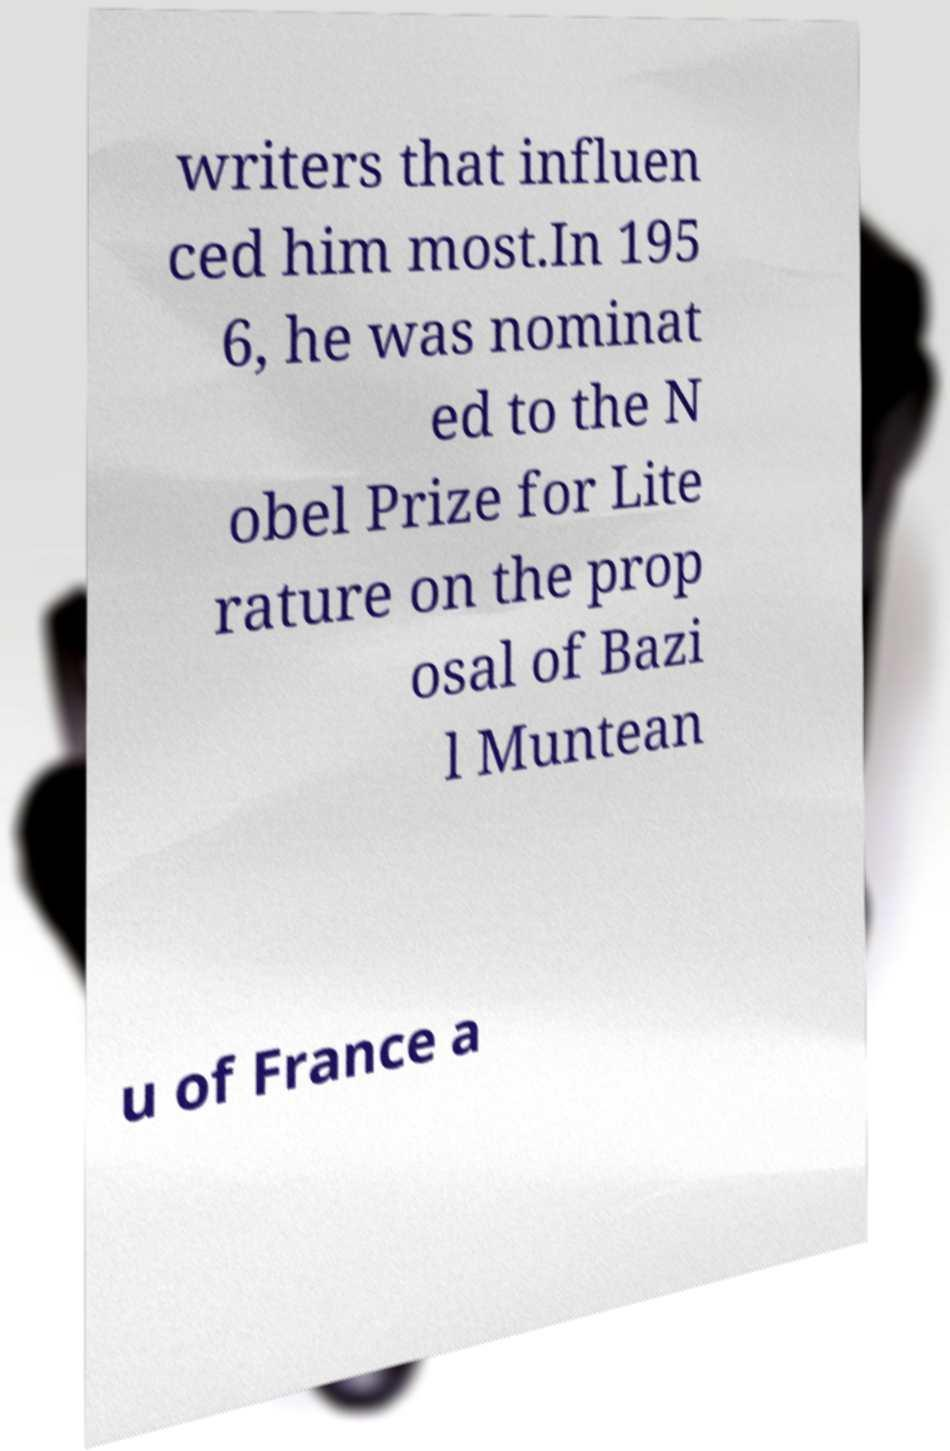Can you read and provide the text displayed in the image?This photo seems to have some interesting text. Can you extract and type it out for me? writers that influen ced him most.In 195 6, he was nominat ed to the N obel Prize for Lite rature on the prop osal of Bazi l Muntean u of France a 